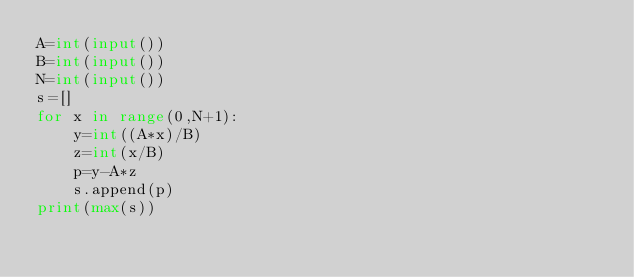<code> <loc_0><loc_0><loc_500><loc_500><_Python_>A=int(input())
B=int(input())
N=int(input())
s=[]
for x in range(0,N+1):
    y=int((A*x)/B)
    z=int(x/B)
    p=y-A*z
    s.append(p)
print(max(s))    

</code> 